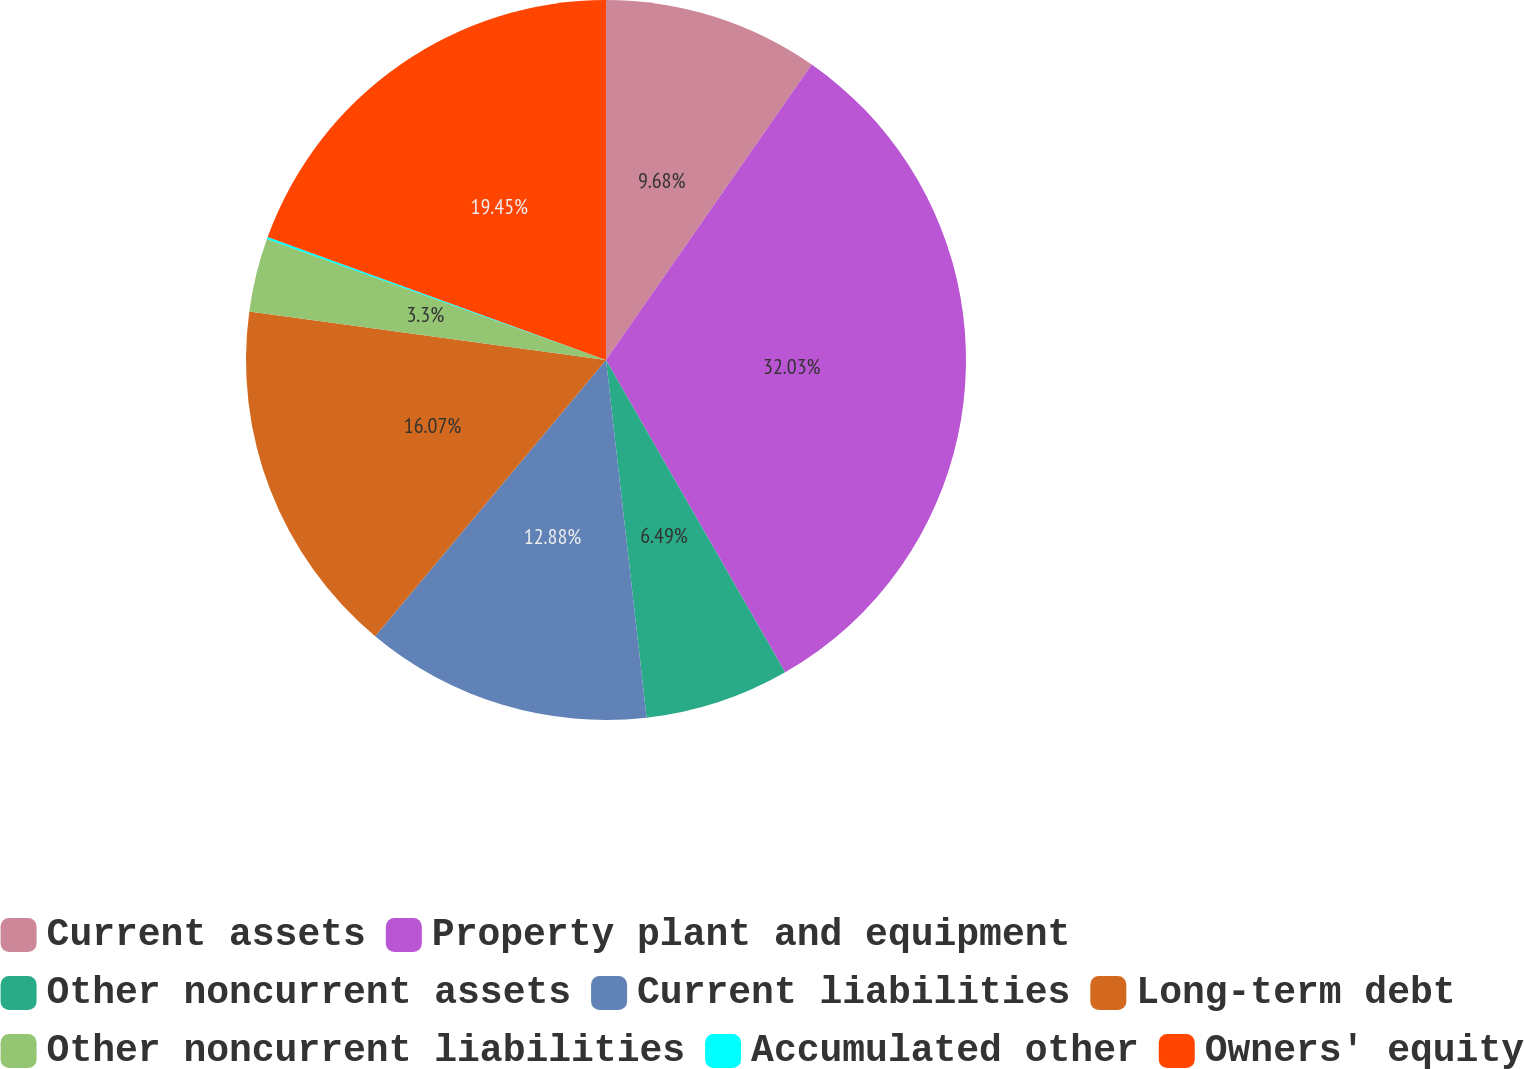Convert chart to OTSL. <chart><loc_0><loc_0><loc_500><loc_500><pie_chart><fcel>Current assets<fcel>Property plant and equipment<fcel>Other noncurrent assets<fcel>Current liabilities<fcel>Long-term debt<fcel>Other noncurrent liabilities<fcel>Accumulated other<fcel>Owners' equity<nl><fcel>9.68%<fcel>32.03%<fcel>6.49%<fcel>12.88%<fcel>16.07%<fcel>3.3%<fcel>0.1%<fcel>19.45%<nl></chart> 